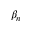<formula> <loc_0><loc_0><loc_500><loc_500>\beta _ { n }</formula> 